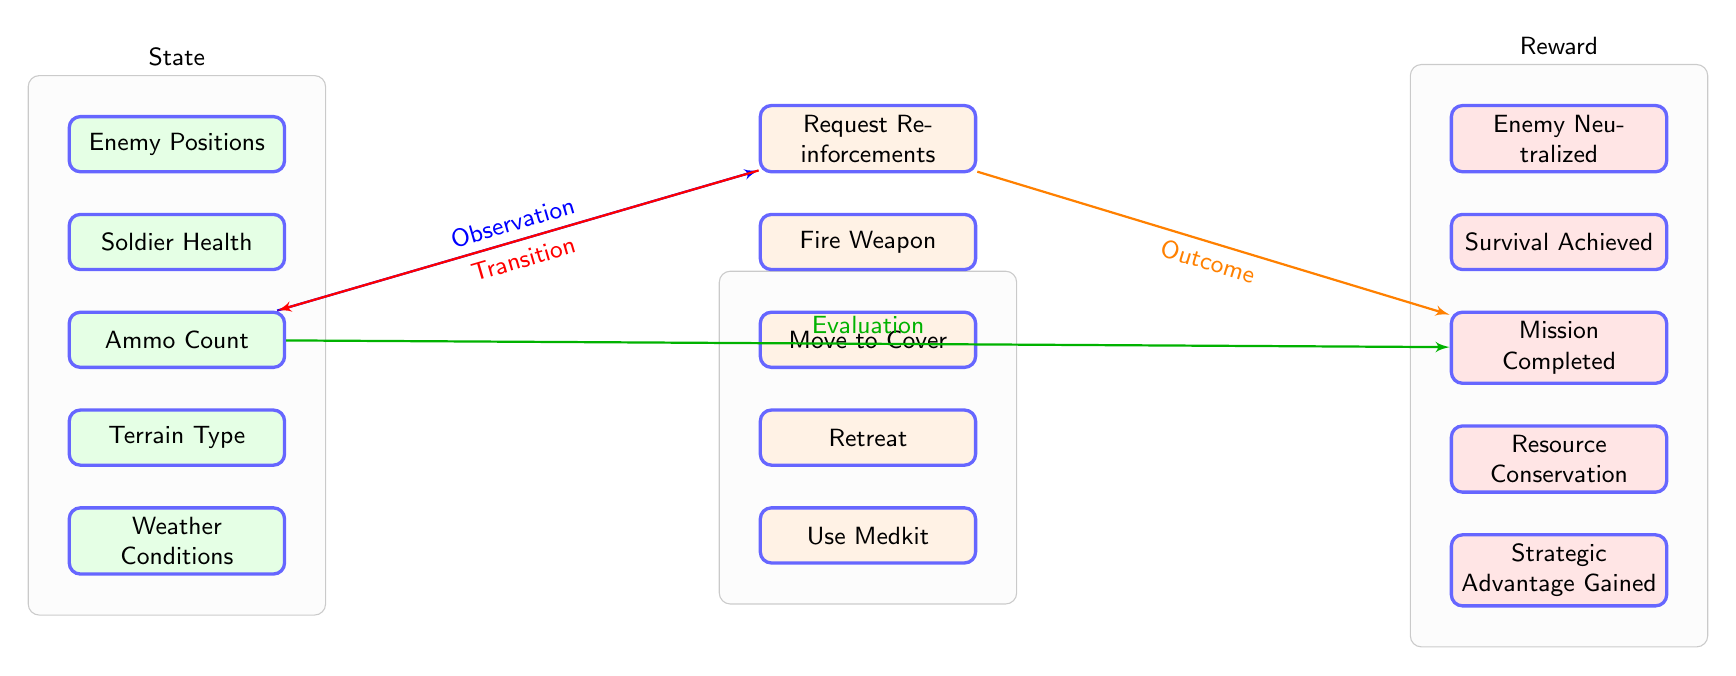What are the states represented in the diagram? The diagram lists five states: Enemy Positions, Soldier Health, Ammo Count, Terrain Type, and Weather Conditions. These are visually depicted in the left column of the diagram.
Answer: Enemy Positions, Soldier Health, Ammo Count, Terrain Type, Weather Conditions How many action nodes are there in the diagram? Counting the action nodes depicted in the right column of the diagram reveals that there are five action nodes: Move to Cover, Fire Weapon, Request Reinforcements, Retreat, and Use Medkit.
Answer: 5 Which action is directly connected to 'Enemy Neutralized'? Tracing the flow from the 'Enemy Neutralized' reward node indicates that it is directly connected to the 'Request Reinforcements' action node, as shown by the line indicating the transition.
Answer: Request Reinforcements What type of evaluation occurs after 'Ammo Count'? The output transitions from 'Ammo Count' to 'Request Reinforcements', and the subsequent evaluation leads to the discussion of 'Mission Completed', indicating that this evaluation assesses the effects tied to ammo usage in strategic contexts.
Answer: Evaluation Which reward node signifies a benefit from effective resource management? The 'Resource Conservation' reward node reflects the benefits derived from managing resources effectively during tactical decision-making. This node shows that sustaining resources is a part of a successful strategy.
Answer: Resource Conservation What is the relationship between 'Survival Achieved' and 'Fire Weapon'? To understand the relationship, trace the flow from 'Fire Weapon' action to 'Survival Achieved' reward. It signifies that an effective action (firing the weapon) contributes to the outcome of achieving survival in a tactical context.
Answer: Transition How do 'Terrain Type' and 'Weather Conditions' influence action choices? Both 'Terrain Type' and 'Weather Conditions' are state nodes that impact the policy for selecting actions, visually indicating that these environmental factors influence tactical decisions such as moving to cover or using weaponry effectively.
Answer: Influence actions What is the main objective of the diagram's flow? The overall flow of the diagram illustrates a decision-making process where the states influence actions, which subsequently yield rewards, aiming to optimize tactics in various scenarios.
Answer: Optimize tactics 